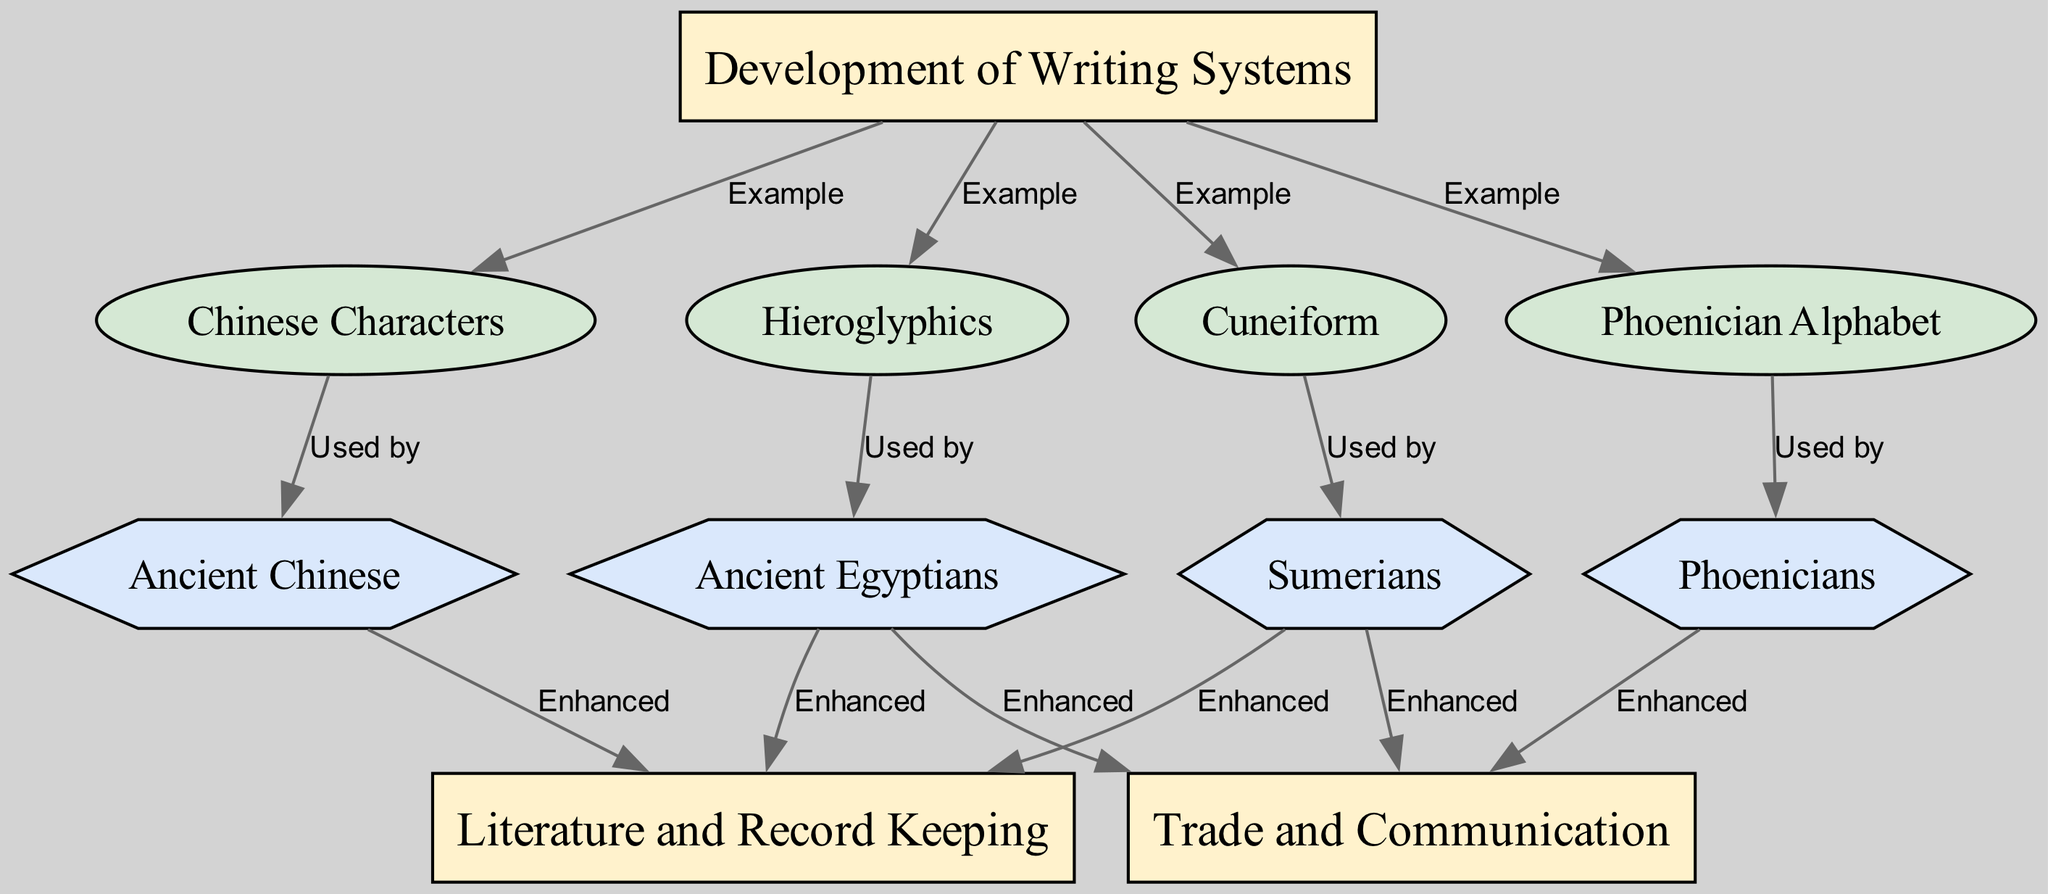What are the writing systems represented in the diagram? The diagram shows four writing systems: Cuneiform, Hieroglyphics, Phoenician Alphabet, and Chinese Characters. Each of these writing systems is directly connected to the category "Development of Writing Systems," indicating they are examples of it.
Answer: Cuneiform, Hieroglyphics, Phoenician Alphabet, Chinese Characters Which civilization used Cuneiform? The arrow from Cuneiform to Sumerians indicates that Cuneiform was used by the Sumerians, demonstrating the direct relationship between this writing system and civilization.
Answer: Sumerians How many civilizations are represented in the diagram? Counting the nodes labeled as civilizations, we find Sumerians, Ancient Egyptians, Phoenicians, and Ancient Chinese, resulting in a total of four civilizations represented in the diagram.
Answer: 4 What is the relationship between Sumerians and Trade and Communication? The edge labeled "Enhanced" connects Sumerians to Trade and Communication, indicating that the development of Cuneiform writing significantly improved the Sumerians’ ability to engage in trade and communication.
Answer: Enhanced Which writing system is associated with Ancient Chinese? The arrow from Chinese Characters points to Ancient Chinese, establishing a direct connection where Ancient Chinese civilization is linked to the use of Chinese Characters as a writing system.
Answer: Chinese Characters What category includes Literature and Record Keeping? The arrows from Sumerians and Ancient Egyptians to the category "Literature and Record Keeping" indicate that both civilizations contributed to this aspect of societal development, reflecting their historical significance in literature.
Answer: Literature and Record Keeping Which civilization is connected to the Phoenician Alphabet? The relationship labeled "Used by" from the Phoenician Alphabet to Phoenicians shows that this writing system was specifically used by the Phoenician civilization.
Answer: Phoenicians How many edges originate from the category "Development of Writing Systems"? The count of edges branching from the "Development of Writing Systems" node shows that there are four writing systems connected to it, which directly illustrates the examples of writing systems within this development category.
Answer: 4 